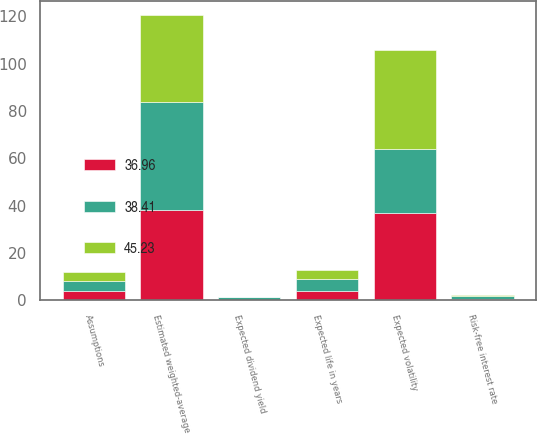Convert chart. <chart><loc_0><loc_0><loc_500><loc_500><stacked_bar_chart><ecel><fcel>Assumptions<fcel>Risk-free interest rate<fcel>Expected life in years<fcel>Expected volatility<fcel>Expected dividend yield<fcel>Estimated weighted-average<nl><fcel>38.41<fcel>4<fcel>1.23<fcel>5<fcel>27<fcel>1.26<fcel>45.23<nl><fcel>36.96<fcel>4<fcel>0.53<fcel>4<fcel>37<fcel>0<fcel>38.41<nl><fcel>45.23<fcel>4<fcel>0.57<fcel>4<fcel>42<fcel>0<fcel>36.96<nl></chart> 